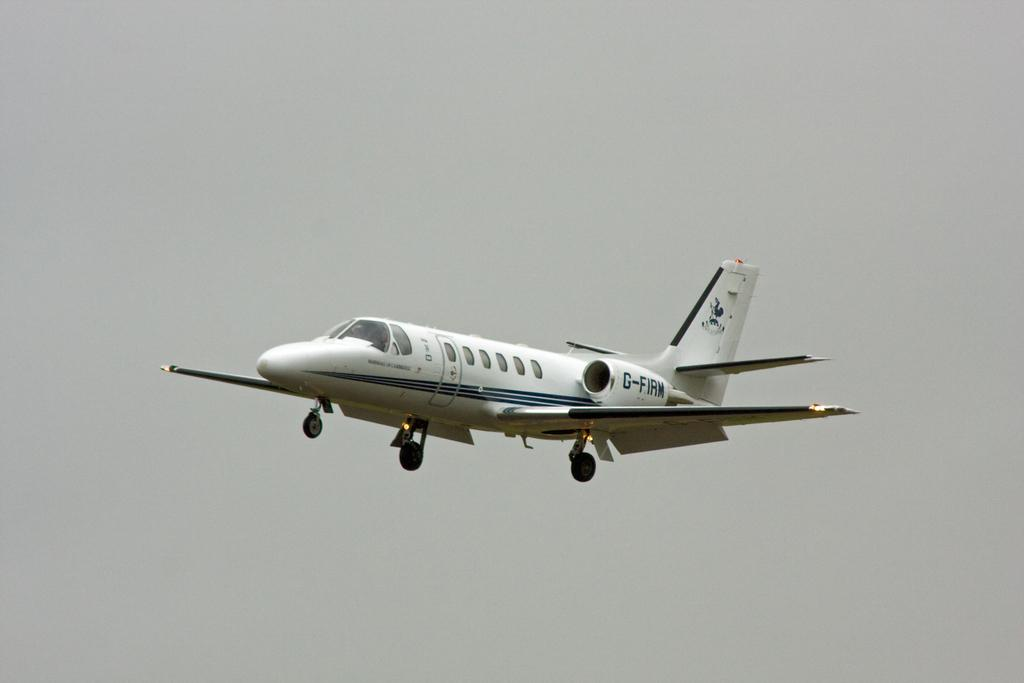What is the main subject of the image? The main subject of the image is an airplane. Where is the airplane located in the image? The airplane is in the sky. What time does the existence of fairies become apparent in the image? There are no fairies present in the image, so their existence or the time of their appearance cannot be determined. 